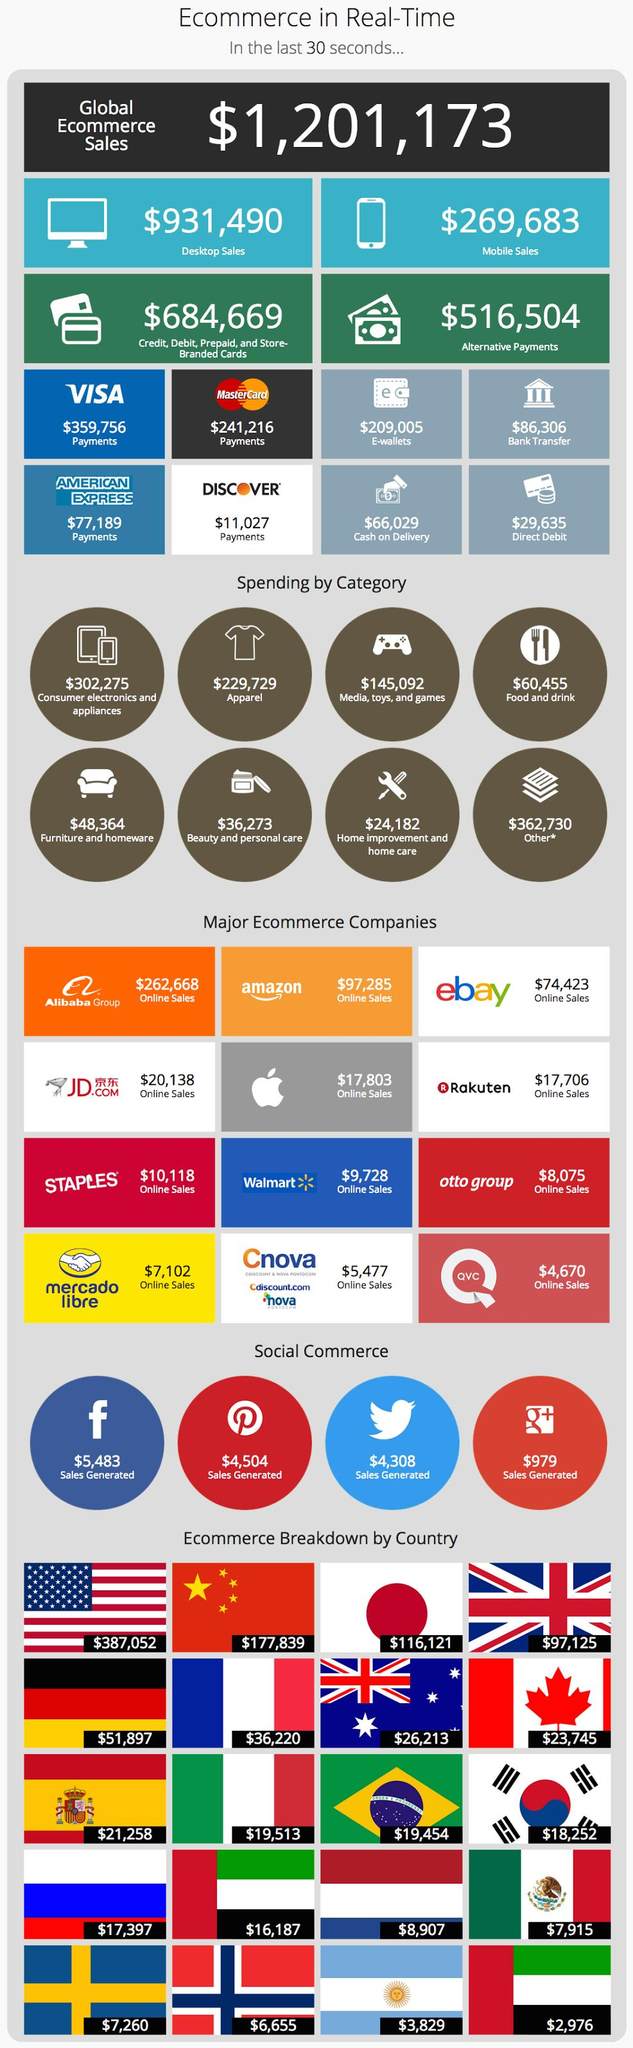Specify some key components in this picture. According to the infographics, the e-commerce value of the United States is approximately $387,052. The number of flags displayed is 20.. The combined sales generated through Twitter and Google Plus were $5,287. Facebook generated $5,483 in sales. 